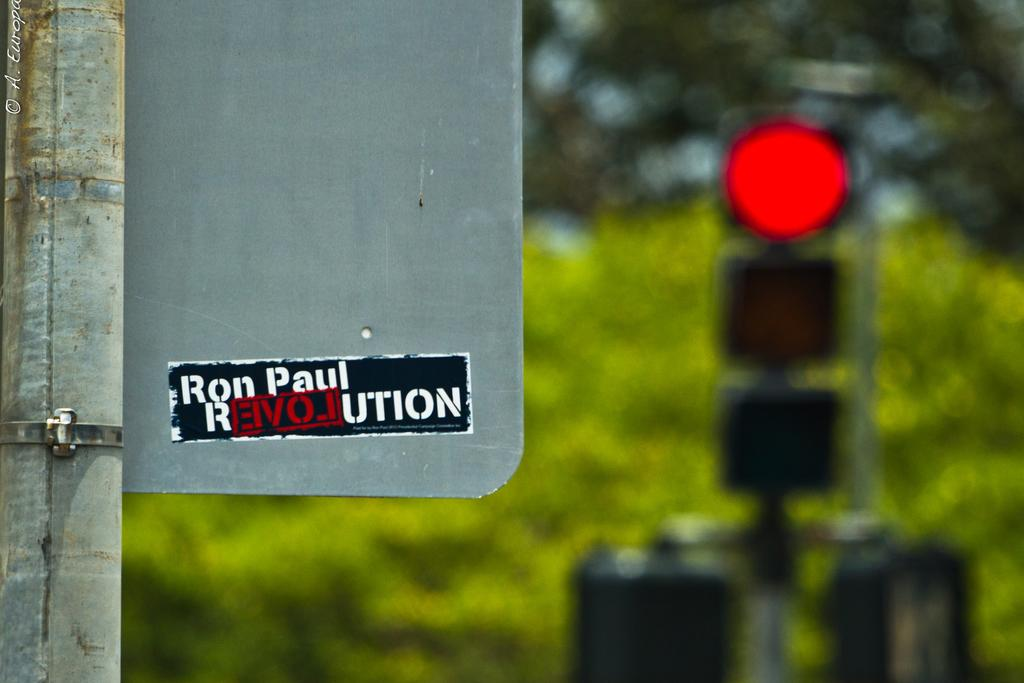What is the main object in the image? There is a board in the image. What is on the board? There is a sticker on the board. What can be seen in the background of the image? There is a traffic light and trees in the background of the image. Where is the dock located in the image? There is no dock present in the image. What type of art is displayed on the board? The image does not provide enough information to determine the type of art on the sticker. 